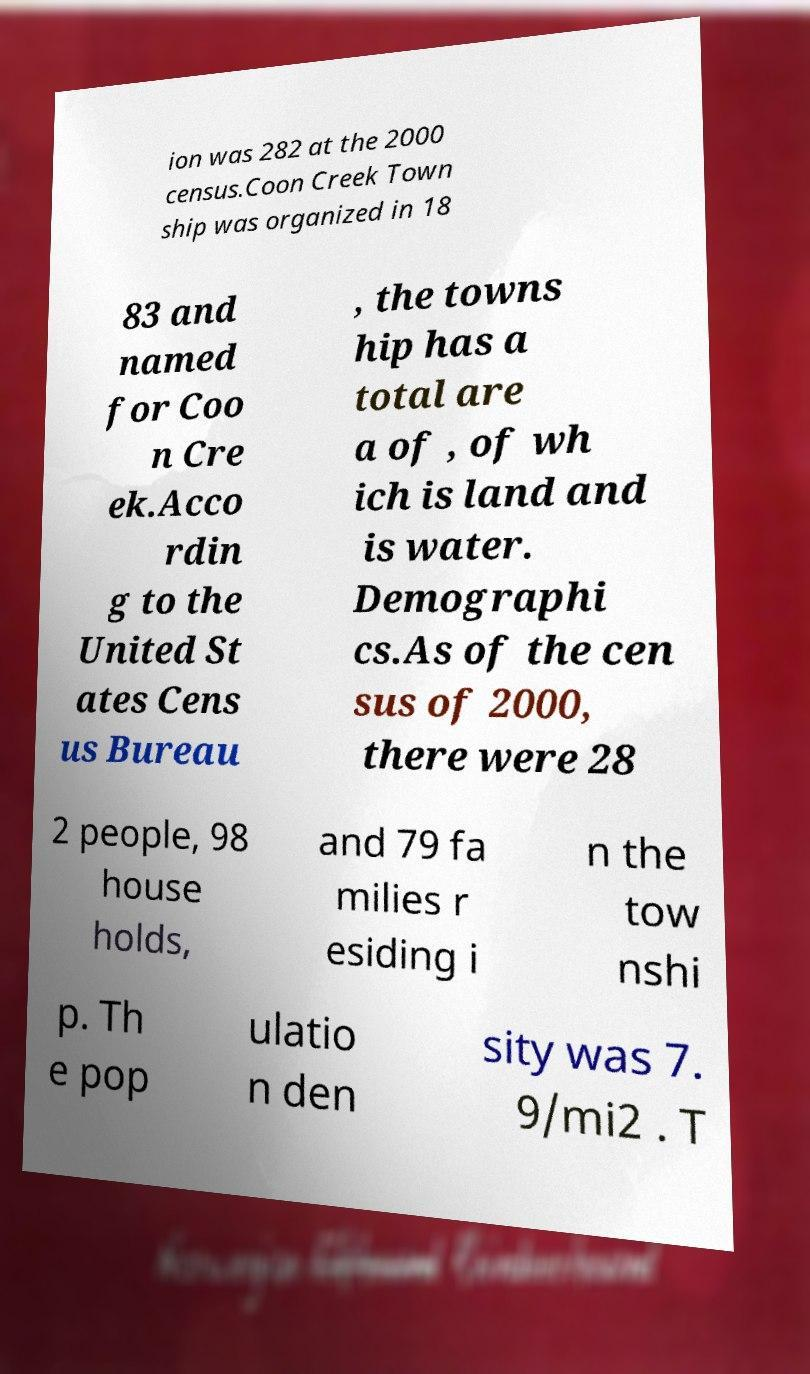I need the written content from this picture converted into text. Can you do that? ion was 282 at the 2000 census.Coon Creek Town ship was organized in 18 83 and named for Coo n Cre ek.Acco rdin g to the United St ates Cens us Bureau , the towns hip has a total are a of , of wh ich is land and is water. Demographi cs.As of the cen sus of 2000, there were 28 2 people, 98 house holds, and 79 fa milies r esiding i n the tow nshi p. Th e pop ulatio n den sity was 7. 9/mi2 . T 